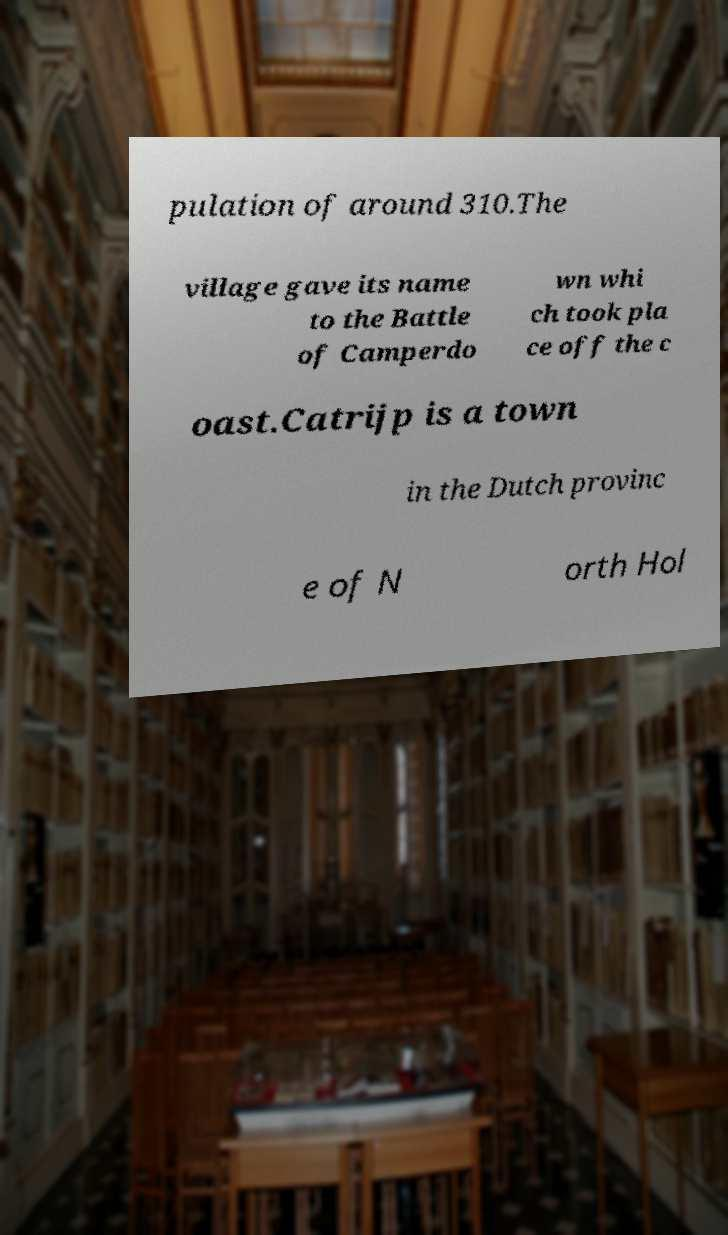Could you extract and type out the text from this image? pulation of around 310.The village gave its name to the Battle of Camperdo wn whi ch took pla ce off the c oast.Catrijp is a town in the Dutch provinc e of N orth Hol 